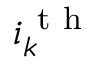<formula> <loc_0><loc_0><loc_500><loc_500>i _ { k } ^ { t h }</formula> 